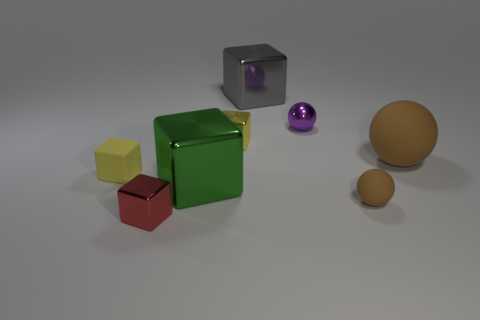There is a object that is the same color as the tiny rubber sphere; what is its size?
Ensure brevity in your answer.  Large. How many purple things have the same shape as the large brown rubber thing?
Provide a short and direct response. 1. There is a rubber ball that is on the right side of the small brown matte ball; does it have the same color as the tiny matte sphere?
Provide a short and direct response. Yes. What number of large objects are in front of the metallic thing in front of the small rubber thing that is to the right of the tiny yellow metallic cube?
Make the answer very short. 0. What number of cubes are in front of the purple metal object and right of the yellow matte block?
Give a very brief answer. 3. There is a metallic thing that is the same color as the matte cube; what is its shape?
Give a very brief answer. Cube. Are the purple object and the green block made of the same material?
Keep it short and to the point. Yes. There is a brown object in front of the brown rubber object that is behind the brown rubber sphere that is in front of the green thing; what shape is it?
Ensure brevity in your answer.  Sphere. Are there fewer large metal blocks that are on the left side of the large brown object than green things that are behind the shiny ball?
Provide a succinct answer. No. There is a brown object left of the large brown matte ball that is right of the metal sphere; what shape is it?
Provide a succinct answer. Sphere. 